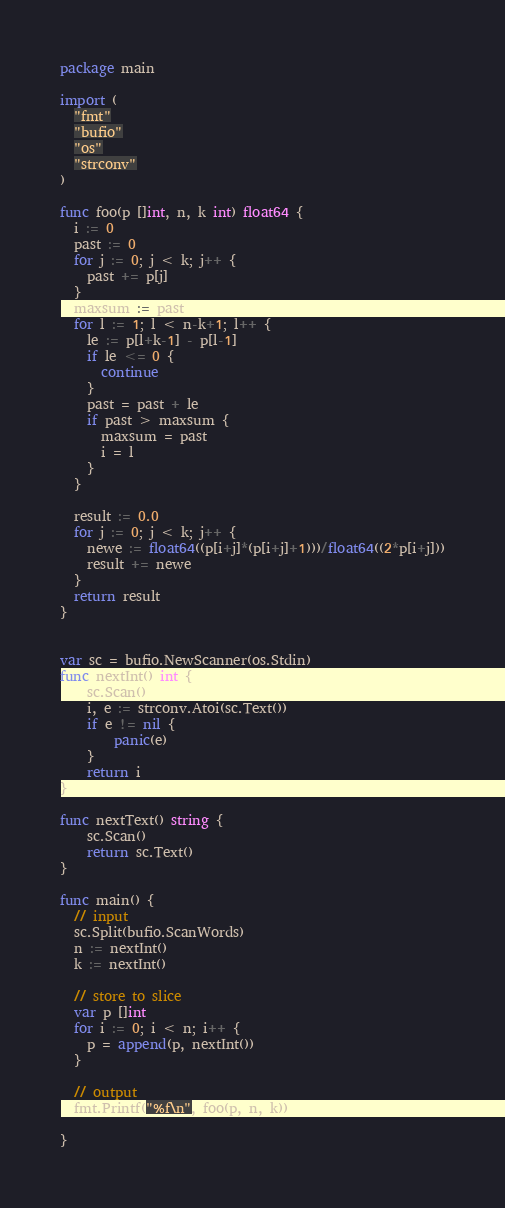Convert code to text. <code><loc_0><loc_0><loc_500><loc_500><_Go_>package main

import (
  "fmt"
  "bufio"
  "os"
  "strconv"
)

func foo(p []int, n, k int) float64 {
  i := 0
  past := 0
  for j := 0; j < k; j++ {
    past += p[j]
  }
  maxsum := past
  for l := 1; l < n-k+1; l++ {
    le := p[l+k-1] - p[l-1]
    if le <= 0 {
      continue
    }
    past = past + le
    if past > maxsum {
      maxsum = past
      i = l
    }
  }

  result := 0.0
  for j := 0; j < k; j++ {
    newe := float64((p[i+j]*(p[i+j]+1)))/float64((2*p[i+j]))
    result += newe
  }
  return result
}


var sc = bufio.NewScanner(os.Stdin)
func nextInt() int {
    sc.Scan()
    i, e := strconv.Atoi(sc.Text())
    if e != nil {
        panic(e)
    }
    return i
}

func nextText() string {
    sc.Scan()
    return sc.Text()
}

func main() {
  // input
  sc.Split(bufio.ScanWords)
  n := nextInt()
  k := nextInt()

  // store to slice
  var p []int
  for i := 0; i < n; i++ {
    p = append(p, nextInt())
  }

  // output
  fmt.Printf("%f\n", foo(p, n, k))

}
</code> 